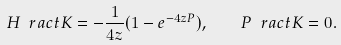Convert formula to latex. <formula><loc_0><loc_0><loc_500><loc_500>H \ r a c t K = - \frac { 1 } { 4 { z } } ( 1 - e ^ { - 4 { z } P } ) , \quad P \ r a c t K = 0 .</formula> 